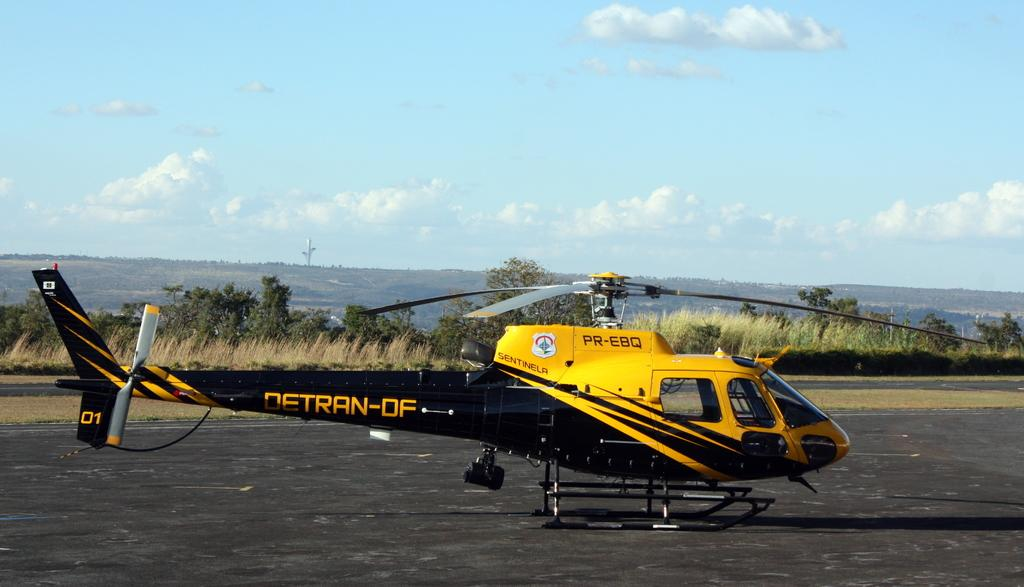<image>
Provide a brief description of the given image. A black and yellow Detran-DF  helicopter is ready to go on a clear day. 